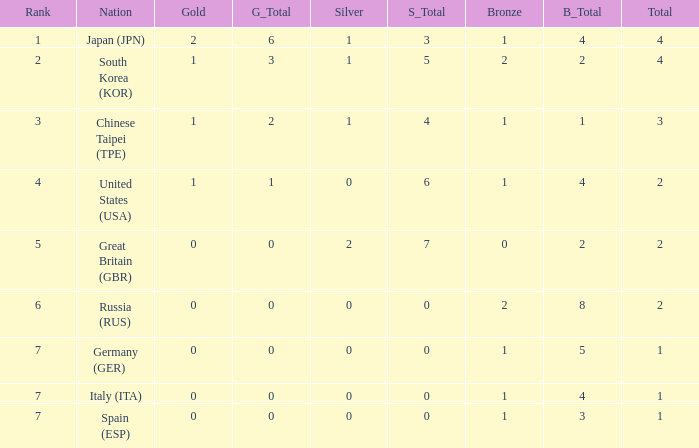What is the rank of the country with more than 2 medals, and 2 gold medals? 1.0. 